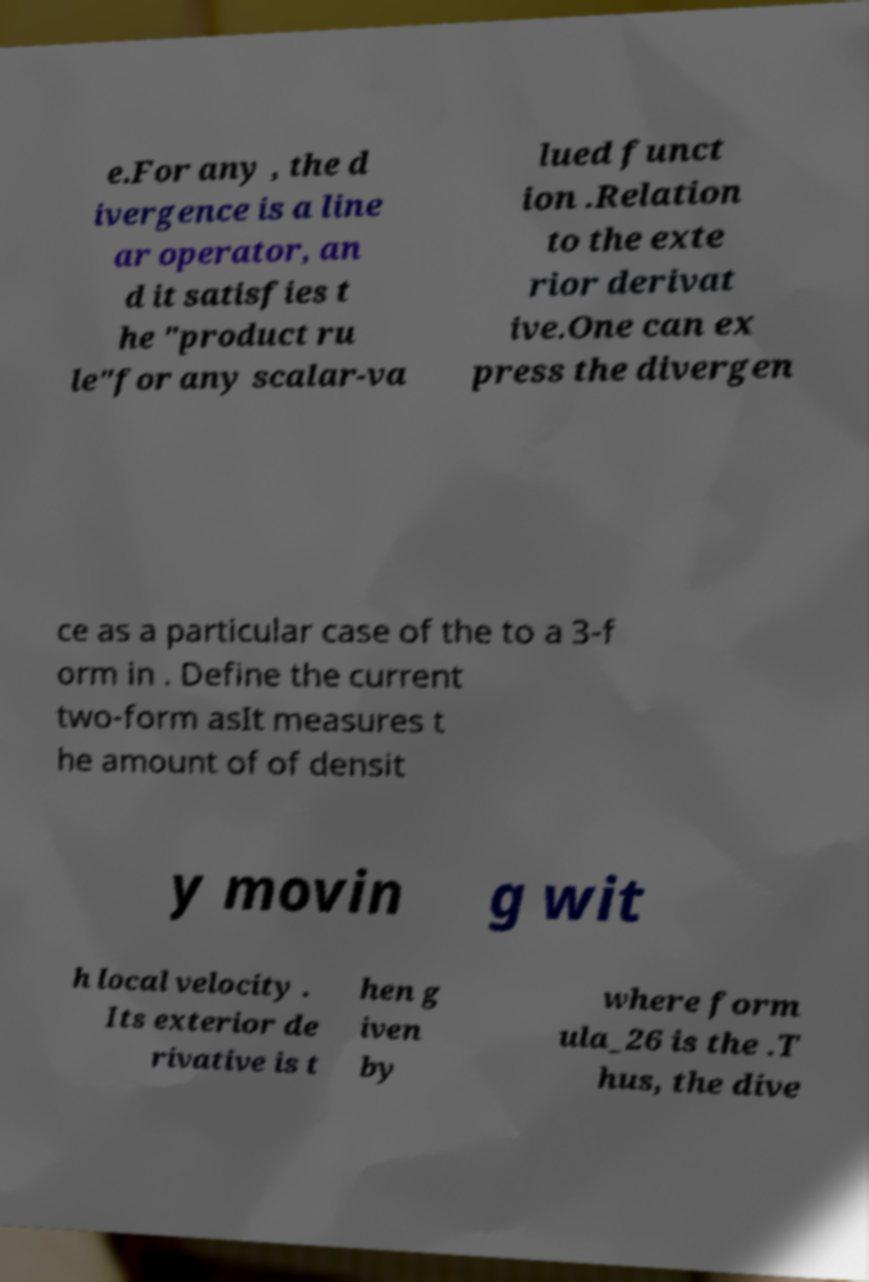What messages or text are displayed in this image? I need them in a readable, typed format. e.For any , the d ivergence is a line ar operator, an d it satisfies t he "product ru le"for any scalar-va lued funct ion .Relation to the exte rior derivat ive.One can ex press the divergen ce as a particular case of the to a 3-f orm in . Define the current two-form asIt measures t he amount of of densit y movin g wit h local velocity . Its exterior de rivative is t hen g iven by where form ula_26 is the .T hus, the dive 